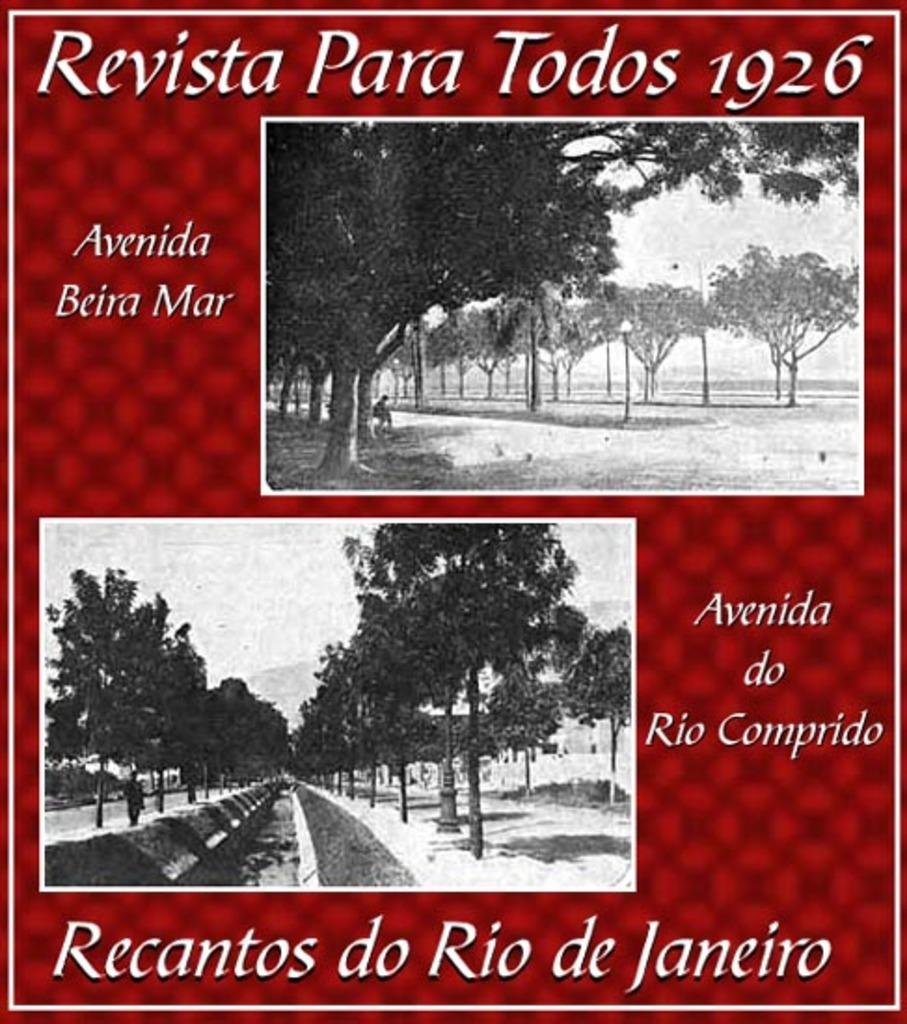What type of artwork is the image? The image is a collage. What type of natural elements can be seen in the image? There are trees in the image. Are there any human elements in the image? Yes, there is a person in the image. What type of soup is being served at the club in the image? There is no club or soup present in the image; it is a collage featuring trees and a person. 